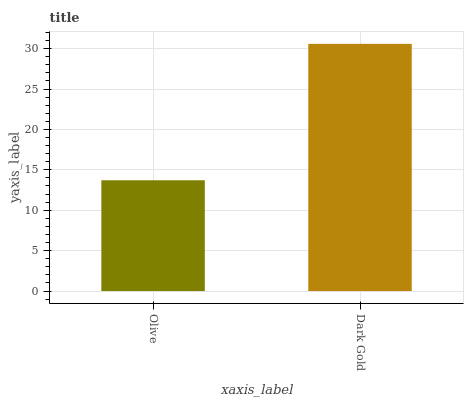Is Olive the minimum?
Answer yes or no. Yes. Is Dark Gold the maximum?
Answer yes or no. Yes. Is Dark Gold the minimum?
Answer yes or no. No. Is Dark Gold greater than Olive?
Answer yes or no. Yes. Is Olive less than Dark Gold?
Answer yes or no. Yes. Is Olive greater than Dark Gold?
Answer yes or no. No. Is Dark Gold less than Olive?
Answer yes or no. No. Is Dark Gold the high median?
Answer yes or no. Yes. Is Olive the low median?
Answer yes or no. Yes. Is Olive the high median?
Answer yes or no. No. Is Dark Gold the low median?
Answer yes or no. No. 